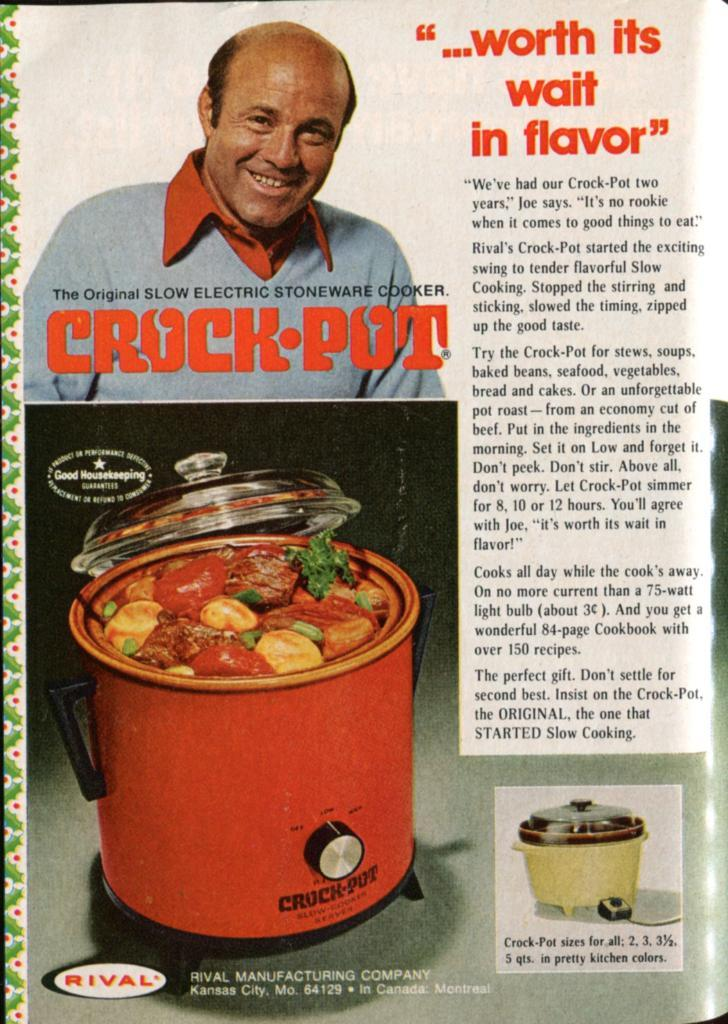<image>
Describe the image concisely. An old looking magazine ad for the crock pot 